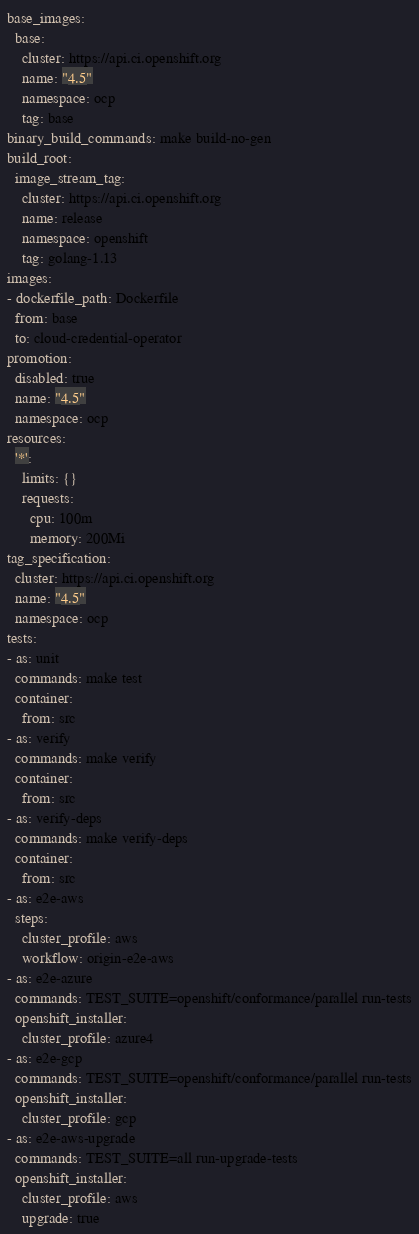Convert code to text. <code><loc_0><loc_0><loc_500><loc_500><_YAML_>base_images:
  base:
    cluster: https://api.ci.openshift.org
    name: "4.5"
    namespace: ocp
    tag: base
binary_build_commands: make build-no-gen
build_root:
  image_stream_tag:
    cluster: https://api.ci.openshift.org
    name: release
    namespace: openshift
    tag: golang-1.13
images:
- dockerfile_path: Dockerfile
  from: base
  to: cloud-credential-operator
promotion:
  disabled: true
  name: "4.5"
  namespace: ocp
resources:
  '*':
    limits: {}
    requests:
      cpu: 100m
      memory: 200Mi
tag_specification:
  cluster: https://api.ci.openshift.org
  name: "4.5"
  namespace: ocp
tests:
- as: unit
  commands: make test
  container:
    from: src
- as: verify
  commands: make verify
  container:
    from: src
- as: verify-deps
  commands: make verify-deps
  container:
    from: src
- as: e2e-aws
  steps:
    cluster_profile: aws
    workflow: origin-e2e-aws
- as: e2e-azure
  commands: TEST_SUITE=openshift/conformance/parallel run-tests
  openshift_installer:
    cluster_profile: azure4
- as: e2e-gcp
  commands: TEST_SUITE=openshift/conformance/parallel run-tests
  openshift_installer:
    cluster_profile: gcp
- as: e2e-aws-upgrade
  commands: TEST_SUITE=all run-upgrade-tests
  openshift_installer:
    cluster_profile: aws
    upgrade: true
</code> 